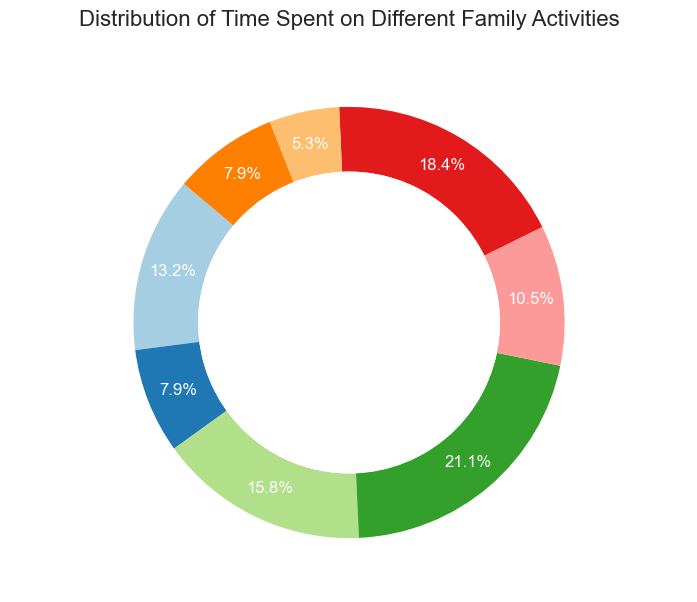Which activity takes up the most time? The segment of the pie chart representing "Family Meals" is the largest one, indicating that more time is spent on this activity compared to others.
Answer: Family Meals How much time is spent in total on Outdoor Play and Chores? From the chart, Outdoor Play is 5 hours per week and Chores is 2 hours per week. Adding these times together gives 5 + 2 = 7 hours.
Answer: 7 hours Which activity requires less time, Homework Help or Family Outings? By comparing the size of the segments, Homework Help is 3 hours per week, and Family Outings are also 3 hours per week. Thus, they require an equal amount of time.
Answer: Equal What is the percentage of time spent on Bedtime Routines? Bedtime Routines' portion of the pie chart shows the specific percentage, which is 6 hours out of the total weekly hours. Calculating the percentage, (6 / 38) * 100 ≈ 15.8%.
Answer: 15.8% How does Screen Time compare to Reading Time in the amount of time spent per week? The chart shows that Screen Time is 7 hours per week, while Reading Time is 4 hours per week. 7 hours is greater than 4 hours.
Answer: Screen Time is greater What is the combined percentage of time spent on Family Meals and Screen Time? The pie chart shows Family Meals is 8 hours and Screen Time is 7 hours. The total weekly hours is 38. Calculating the percentage, ((8 + 7) / 38) * 100 = 39.5%.
Answer: 39.5% What is the average time spent across all activities? Summing the total hours spent on all activities gives us 38 hours. Dividing by the number of activities (8) results in an average of 38 / 8 = 4.75 hours per activity.
Answer: 4.75 hours Which activity takes up more time, Bedtime Routines or Outdoor Play? Comparing the segments, Bedtime Routines is 6 hours per week, while Outdoor Play is 5 hours per week. 6 hours is greater than 5 hours.
Answer: Bedtime Routines Which is the least time-consuming activity? The smallest segment of the pie chart represents "Chores," indicating it takes up the least time at 2 hours per week.
Answer: Chores Is Family Meals more than double the time spent on Chores? Family Meals is 8 hours and Chores is 2 hours per week. 8 hours is more than double 2 hours (2 * 2 = 4), so yes, Family Meals takes more than double the time.
Answer: Yes 